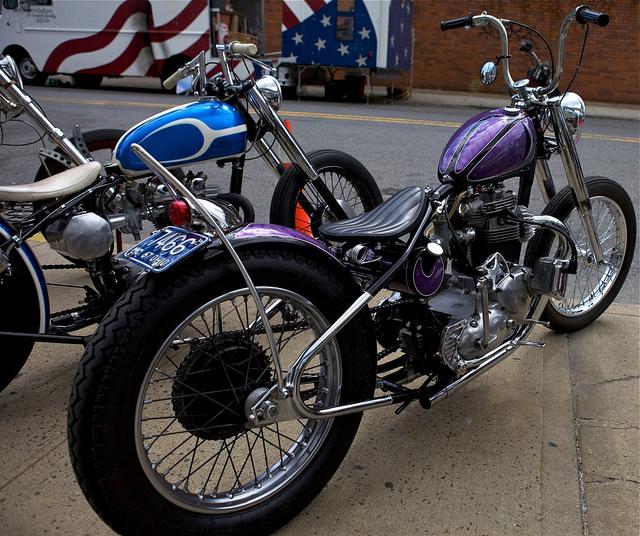Do they appear to be identical motorcycles?
Quick response, please. No. Do the owners of these vehicles own helmets?
Answer briefly. Yes. What color is the motorcycle on the right?
Write a very short answer. Purple. Which one is blue and white?
Concise answer only. Left. What color is the bike?
Quick response, please. Purple. What is the id number on the motorcycle?
Answer briefly. 7466. What is the number on the right cycle?
Give a very brief answer. 7466. What color is this motorcycle?
Keep it brief. Purple. What color is the bike that's the closest?
Keep it brief. Purple. How many motorcycles are there?
Short answer required. 2. How many bikes are in the picture?
Give a very brief answer. 2. What type of motorcycle is the people one?
Give a very brief answer. Harley. How many wheels is on this vehicle?
Answer briefly. 2. What color is this bike?
Quick response, please. Purple. Are these old motorbikes?
Write a very short answer. No. How many motorcycles?
Keep it brief. 2. Are these motorcycles the same size?
Be succinct. Yes. What color is the bike on the right?
Write a very short answer. Purple. 